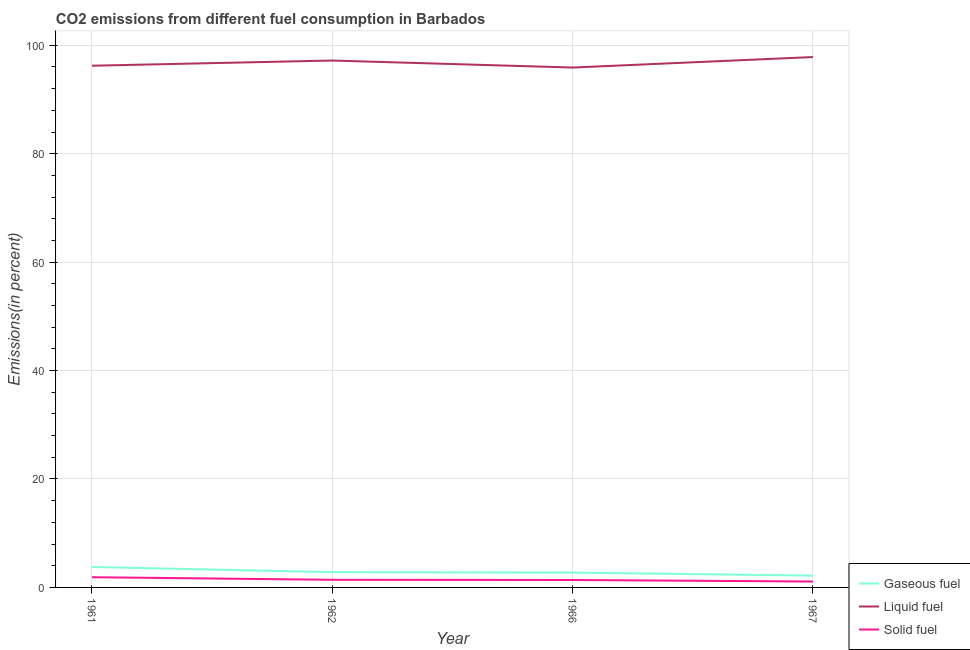How many different coloured lines are there?
Offer a very short reply. 3. What is the percentage of solid fuel emission in 1967?
Provide a short and direct response. 1.09. Across all years, what is the maximum percentage of liquid fuel emission?
Your answer should be very brief. 97.83. Across all years, what is the minimum percentage of liquid fuel emission?
Provide a short and direct response. 95.89. In which year was the percentage of liquid fuel emission minimum?
Make the answer very short. 1966. What is the total percentage of solid fuel emission in the graph?
Provide a short and direct response. 5.75. What is the difference between the percentage of liquid fuel emission in 1962 and that in 1966?
Ensure brevity in your answer.  1.29. What is the difference between the percentage of liquid fuel emission in 1962 and the percentage of solid fuel emission in 1966?
Ensure brevity in your answer.  95.81. What is the average percentage of solid fuel emission per year?
Your answer should be very brief. 1.44. In the year 1967, what is the difference between the percentage of solid fuel emission and percentage of liquid fuel emission?
Provide a succinct answer. -96.74. What is the ratio of the percentage of gaseous fuel emission in 1961 to that in 1967?
Keep it short and to the point. 1.74. Is the difference between the percentage of solid fuel emission in 1961 and 1962 greater than the difference between the percentage of gaseous fuel emission in 1961 and 1962?
Provide a short and direct response. No. What is the difference between the highest and the second highest percentage of solid fuel emission?
Keep it short and to the point. 0.48. What is the difference between the highest and the lowest percentage of solid fuel emission?
Offer a very short reply. 0.8. In how many years, is the percentage of solid fuel emission greater than the average percentage of solid fuel emission taken over all years?
Ensure brevity in your answer.  1. Is the sum of the percentage of solid fuel emission in 1961 and 1967 greater than the maximum percentage of liquid fuel emission across all years?
Your answer should be very brief. No. Does the percentage of gaseous fuel emission monotonically increase over the years?
Provide a short and direct response. No. Is the percentage of liquid fuel emission strictly greater than the percentage of gaseous fuel emission over the years?
Offer a terse response. Yes. Is the percentage of liquid fuel emission strictly less than the percentage of solid fuel emission over the years?
Offer a terse response. No. How many lines are there?
Your answer should be very brief. 3. Does the graph contain grids?
Provide a short and direct response. Yes. Where does the legend appear in the graph?
Offer a very short reply. Bottom right. How are the legend labels stacked?
Make the answer very short. Vertical. What is the title of the graph?
Your answer should be compact. CO2 emissions from different fuel consumption in Barbados. What is the label or title of the X-axis?
Your answer should be very brief. Year. What is the label or title of the Y-axis?
Provide a short and direct response. Emissions(in percent). What is the Emissions(in percent) in Gaseous fuel in 1961?
Your response must be concise. 3.77. What is the Emissions(in percent) in Liquid fuel in 1961?
Your response must be concise. 96.23. What is the Emissions(in percent) of Solid fuel in 1961?
Offer a very short reply. 1.89. What is the Emissions(in percent) of Gaseous fuel in 1962?
Offer a very short reply. 2.82. What is the Emissions(in percent) in Liquid fuel in 1962?
Offer a very short reply. 97.18. What is the Emissions(in percent) in Solid fuel in 1962?
Give a very brief answer. 1.41. What is the Emissions(in percent) of Gaseous fuel in 1966?
Offer a very short reply. 2.74. What is the Emissions(in percent) of Liquid fuel in 1966?
Your response must be concise. 95.89. What is the Emissions(in percent) of Solid fuel in 1966?
Keep it short and to the point. 1.37. What is the Emissions(in percent) of Gaseous fuel in 1967?
Your answer should be compact. 2.17. What is the Emissions(in percent) of Liquid fuel in 1967?
Your answer should be compact. 97.83. What is the Emissions(in percent) of Solid fuel in 1967?
Give a very brief answer. 1.09. Across all years, what is the maximum Emissions(in percent) of Gaseous fuel?
Your response must be concise. 3.77. Across all years, what is the maximum Emissions(in percent) of Liquid fuel?
Provide a short and direct response. 97.83. Across all years, what is the maximum Emissions(in percent) in Solid fuel?
Offer a terse response. 1.89. Across all years, what is the minimum Emissions(in percent) in Gaseous fuel?
Provide a succinct answer. 2.17. Across all years, what is the minimum Emissions(in percent) in Liquid fuel?
Provide a short and direct response. 95.89. Across all years, what is the minimum Emissions(in percent) in Solid fuel?
Provide a short and direct response. 1.09. What is the total Emissions(in percent) of Gaseous fuel in the graph?
Provide a succinct answer. 11.5. What is the total Emissions(in percent) in Liquid fuel in the graph?
Provide a succinct answer. 387.13. What is the total Emissions(in percent) in Solid fuel in the graph?
Provide a short and direct response. 5.75. What is the difference between the Emissions(in percent) of Gaseous fuel in 1961 and that in 1962?
Give a very brief answer. 0.96. What is the difference between the Emissions(in percent) in Liquid fuel in 1961 and that in 1962?
Your answer should be compact. -0.96. What is the difference between the Emissions(in percent) in Solid fuel in 1961 and that in 1962?
Give a very brief answer. 0.48. What is the difference between the Emissions(in percent) in Gaseous fuel in 1961 and that in 1966?
Ensure brevity in your answer.  1.03. What is the difference between the Emissions(in percent) of Liquid fuel in 1961 and that in 1966?
Provide a succinct answer. 0.34. What is the difference between the Emissions(in percent) in Solid fuel in 1961 and that in 1966?
Your response must be concise. 0.52. What is the difference between the Emissions(in percent) in Gaseous fuel in 1961 and that in 1967?
Ensure brevity in your answer.  1.6. What is the difference between the Emissions(in percent) of Liquid fuel in 1961 and that in 1967?
Offer a terse response. -1.6. What is the difference between the Emissions(in percent) of Solid fuel in 1961 and that in 1967?
Provide a short and direct response. 0.8. What is the difference between the Emissions(in percent) of Gaseous fuel in 1962 and that in 1966?
Offer a very short reply. 0.08. What is the difference between the Emissions(in percent) in Liquid fuel in 1962 and that in 1966?
Keep it short and to the point. 1.29. What is the difference between the Emissions(in percent) in Solid fuel in 1962 and that in 1966?
Provide a short and direct response. 0.04. What is the difference between the Emissions(in percent) in Gaseous fuel in 1962 and that in 1967?
Offer a terse response. 0.64. What is the difference between the Emissions(in percent) in Liquid fuel in 1962 and that in 1967?
Offer a very short reply. -0.64. What is the difference between the Emissions(in percent) in Solid fuel in 1962 and that in 1967?
Provide a succinct answer. 0.32. What is the difference between the Emissions(in percent) in Gaseous fuel in 1966 and that in 1967?
Your answer should be very brief. 0.57. What is the difference between the Emissions(in percent) of Liquid fuel in 1966 and that in 1967?
Keep it short and to the point. -1.94. What is the difference between the Emissions(in percent) in Solid fuel in 1966 and that in 1967?
Offer a very short reply. 0.28. What is the difference between the Emissions(in percent) of Gaseous fuel in 1961 and the Emissions(in percent) of Liquid fuel in 1962?
Keep it short and to the point. -93.41. What is the difference between the Emissions(in percent) in Gaseous fuel in 1961 and the Emissions(in percent) in Solid fuel in 1962?
Give a very brief answer. 2.37. What is the difference between the Emissions(in percent) in Liquid fuel in 1961 and the Emissions(in percent) in Solid fuel in 1962?
Give a very brief answer. 94.82. What is the difference between the Emissions(in percent) of Gaseous fuel in 1961 and the Emissions(in percent) of Liquid fuel in 1966?
Provide a succinct answer. -92.12. What is the difference between the Emissions(in percent) in Gaseous fuel in 1961 and the Emissions(in percent) in Solid fuel in 1966?
Ensure brevity in your answer.  2.4. What is the difference between the Emissions(in percent) in Liquid fuel in 1961 and the Emissions(in percent) in Solid fuel in 1966?
Provide a succinct answer. 94.86. What is the difference between the Emissions(in percent) in Gaseous fuel in 1961 and the Emissions(in percent) in Liquid fuel in 1967?
Make the answer very short. -94.05. What is the difference between the Emissions(in percent) in Gaseous fuel in 1961 and the Emissions(in percent) in Solid fuel in 1967?
Provide a succinct answer. 2.69. What is the difference between the Emissions(in percent) in Liquid fuel in 1961 and the Emissions(in percent) in Solid fuel in 1967?
Make the answer very short. 95.14. What is the difference between the Emissions(in percent) in Gaseous fuel in 1962 and the Emissions(in percent) in Liquid fuel in 1966?
Your answer should be compact. -93.07. What is the difference between the Emissions(in percent) of Gaseous fuel in 1962 and the Emissions(in percent) of Solid fuel in 1966?
Offer a very short reply. 1.45. What is the difference between the Emissions(in percent) in Liquid fuel in 1962 and the Emissions(in percent) in Solid fuel in 1966?
Provide a short and direct response. 95.81. What is the difference between the Emissions(in percent) in Gaseous fuel in 1962 and the Emissions(in percent) in Liquid fuel in 1967?
Ensure brevity in your answer.  -95.01. What is the difference between the Emissions(in percent) in Gaseous fuel in 1962 and the Emissions(in percent) in Solid fuel in 1967?
Provide a succinct answer. 1.73. What is the difference between the Emissions(in percent) of Liquid fuel in 1962 and the Emissions(in percent) of Solid fuel in 1967?
Give a very brief answer. 96.1. What is the difference between the Emissions(in percent) of Gaseous fuel in 1966 and the Emissions(in percent) of Liquid fuel in 1967?
Provide a succinct answer. -95.09. What is the difference between the Emissions(in percent) of Gaseous fuel in 1966 and the Emissions(in percent) of Solid fuel in 1967?
Your answer should be very brief. 1.65. What is the difference between the Emissions(in percent) in Liquid fuel in 1966 and the Emissions(in percent) in Solid fuel in 1967?
Your answer should be very brief. 94.8. What is the average Emissions(in percent) of Gaseous fuel per year?
Offer a very short reply. 2.88. What is the average Emissions(in percent) in Liquid fuel per year?
Offer a very short reply. 96.78. What is the average Emissions(in percent) in Solid fuel per year?
Ensure brevity in your answer.  1.44. In the year 1961, what is the difference between the Emissions(in percent) of Gaseous fuel and Emissions(in percent) of Liquid fuel?
Provide a succinct answer. -92.45. In the year 1961, what is the difference between the Emissions(in percent) of Gaseous fuel and Emissions(in percent) of Solid fuel?
Your answer should be compact. 1.89. In the year 1961, what is the difference between the Emissions(in percent) in Liquid fuel and Emissions(in percent) in Solid fuel?
Your answer should be very brief. 94.34. In the year 1962, what is the difference between the Emissions(in percent) of Gaseous fuel and Emissions(in percent) of Liquid fuel?
Provide a short and direct response. -94.37. In the year 1962, what is the difference between the Emissions(in percent) of Gaseous fuel and Emissions(in percent) of Solid fuel?
Your answer should be compact. 1.41. In the year 1962, what is the difference between the Emissions(in percent) in Liquid fuel and Emissions(in percent) in Solid fuel?
Keep it short and to the point. 95.77. In the year 1966, what is the difference between the Emissions(in percent) of Gaseous fuel and Emissions(in percent) of Liquid fuel?
Give a very brief answer. -93.15. In the year 1966, what is the difference between the Emissions(in percent) of Gaseous fuel and Emissions(in percent) of Solid fuel?
Your response must be concise. 1.37. In the year 1966, what is the difference between the Emissions(in percent) in Liquid fuel and Emissions(in percent) in Solid fuel?
Your answer should be compact. 94.52. In the year 1967, what is the difference between the Emissions(in percent) of Gaseous fuel and Emissions(in percent) of Liquid fuel?
Make the answer very short. -95.65. In the year 1967, what is the difference between the Emissions(in percent) of Gaseous fuel and Emissions(in percent) of Solid fuel?
Provide a short and direct response. 1.09. In the year 1967, what is the difference between the Emissions(in percent) in Liquid fuel and Emissions(in percent) in Solid fuel?
Keep it short and to the point. 96.74. What is the ratio of the Emissions(in percent) in Gaseous fuel in 1961 to that in 1962?
Offer a very short reply. 1.34. What is the ratio of the Emissions(in percent) in Liquid fuel in 1961 to that in 1962?
Make the answer very short. 0.99. What is the ratio of the Emissions(in percent) of Solid fuel in 1961 to that in 1962?
Make the answer very short. 1.34. What is the ratio of the Emissions(in percent) in Gaseous fuel in 1961 to that in 1966?
Keep it short and to the point. 1.38. What is the ratio of the Emissions(in percent) in Solid fuel in 1961 to that in 1966?
Your response must be concise. 1.38. What is the ratio of the Emissions(in percent) in Gaseous fuel in 1961 to that in 1967?
Offer a very short reply. 1.74. What is the ratio of the Emissions(in percent) of Liquid fuel in 1961 to that in 1967?
Make the answer very short. 0.98. What is the ratio of the Emissions(in percent) in Solid fuel in 1961 to that in 1967?
Offer a terse response. 1.74. What is the ratio of the Emissions(in percent) of Gaseous fuel in 1962 to that in 1966?
Your answer should be compact. 1.03. What is the ratio of the Emissions(in percent) in Liquid fuel in 1962 to that in 1966?
Give a very brief answer. 1.01. What is the ratio of the Emissions(in percent) in Solid fuel in 1962 to that in 1966?
Provide a succinct answer. 1.03. What is the ratio of the Emissions(in percent) of Gaseous fuel in 1962 to that in 1967?
Keep it short and to the point. 1.3. What is the ratio of the Emissions(in percent) in Solid fuel in 1962 to that in 1967?
Offer a terse response. 1.3. What is the ratio of the Emissions(in percent) of Gaseous fuel in 1966 to that in 1967?
Give a very brief answer. 1.26. What is the ratio of the Emissions(in percent) in Liquid fuel in 1966 to that in 1967?
Your response must be concise. 0.98. What is the ratio of the Emissions(in percent) in Solid fuel in 1966 to that in 1967?
Ensure brevity in your answer.  1.26. What is the difference between the highest and the second highest Emissions(in percent) in Gaseous fuel?
Your response must be concise. 0.96. What is the difference between the highest and the second highest Emissions(in percent) of Liquid fuel?
Ensure brevity in your answer.  0.64. What is the difference between the highest and the second highest Emissions(in percent) in Solid fuel?
Offer a very short reply. 0.48. What is the difference between the highest and the lowest Emissions(in percent) of Gaseous fuel?
Your answer should be compact. 1.6. What is the difference between the highest and the lowest Emissions(in percent) of Liquid fuel?
Your answer should be compact. 1.94. What is the difference between the highest and the lowest Emissions(in percent) of Solid fuel?
Your answer should be very brief. 0.8. 